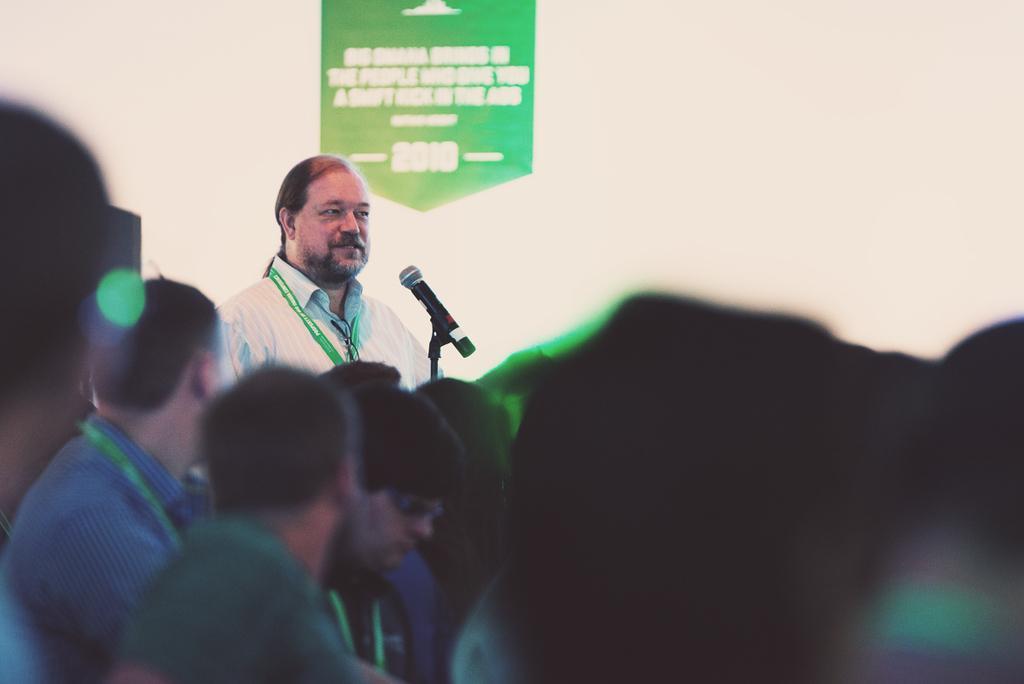In one or two sentences, can you explain what this image depicts? In this image I can see number of people and I can see few of them are wearing ID cards. In the background I can see a mic, a green colour thing and on it I can see something is written. I can also see this image is little bit blurry. 